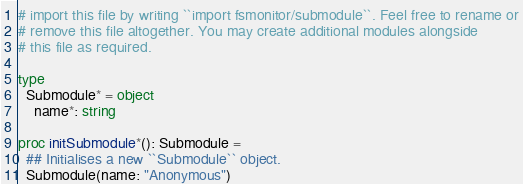Convert code to text. <code><loc_0><loc_0><loc_500><loc_500><_Nim_># import this file by writing ``import fsmonitor/submodule``. Feel free to rename or
# remove this file altogether. You may create additional modules alongside
# this file as required.

type
  Submodule* = object
    name*: string

proc initSubmodule*(): Submodule =
  ## Initialises a new ``Submodule`` object.
  Submodule(name: "Anonymous")
</code> 